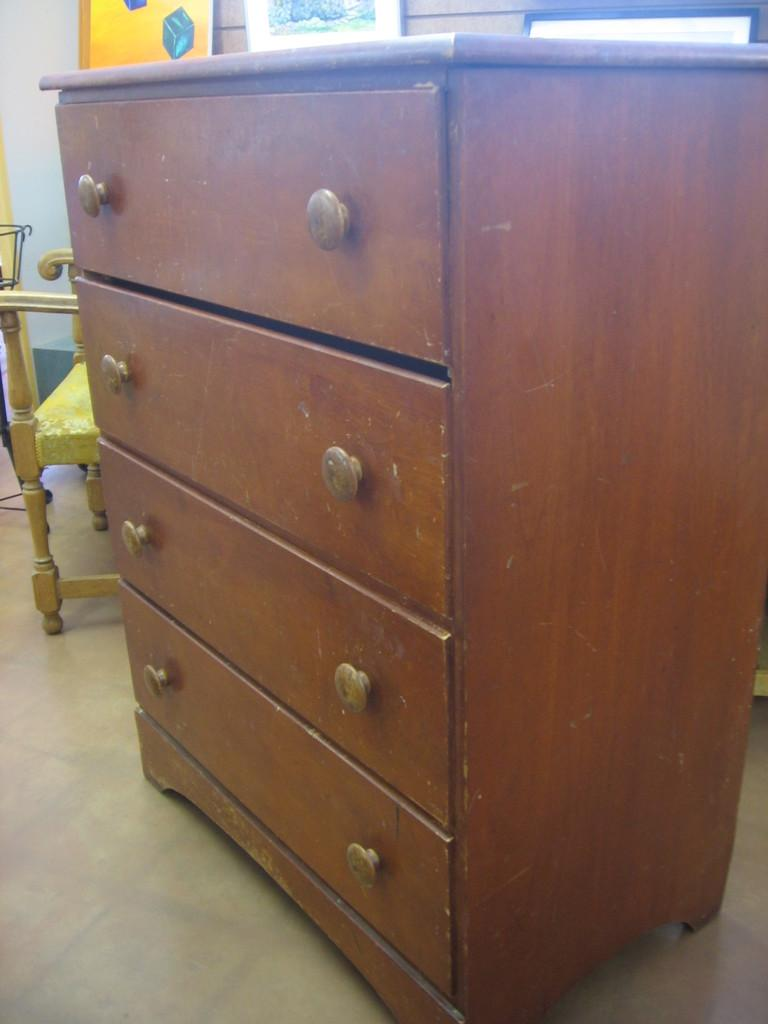What type of furniture is present in the image? There is a wardrobe in the image. What type of tree is growing inside the wardrobe in the image? There is no tree growing inside the wardrobe in the image, as the fact only mentions the presence of a wardrobe. 